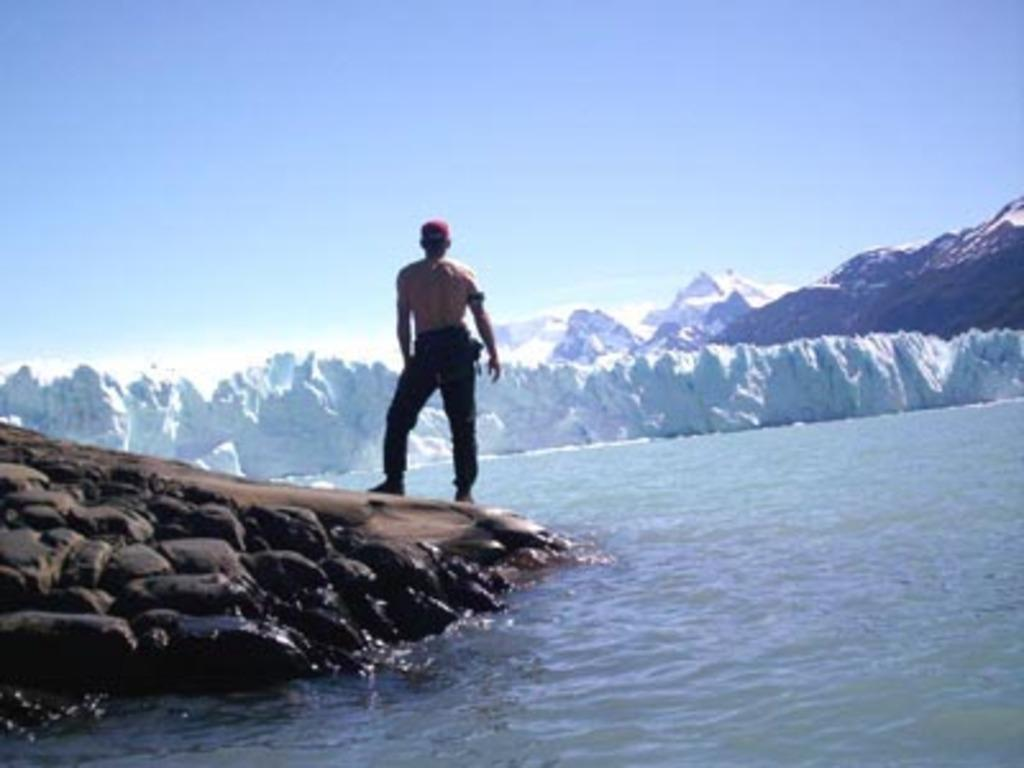What is the man in the image wearing on his feet? The man is wearing shoes in the image. What type of clothing is the man wearing on his head? The man is wearing a cap in the image. What type of terrain is visible in the image? There are stones, water, and snow visible in the image. What is the largest geographical feature in the image? There is a mountain in the image. What is the color of the sky in the image? The sky is blue in the image. What type of debt is the man holding in the image? There is no debt visible in the image; the man is not holding any financial documents or objects related to debt. 